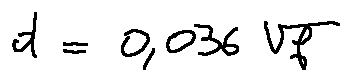Convert formula to latex. <formula><loc_0><loc_0><loc_500><loc_500>d = 0 , 0 3 6 \sqrt { f }</formula> 